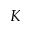Convert formula to latex. <formula><loc_0><loc_0><loc_500><loc_500>K</formula> 